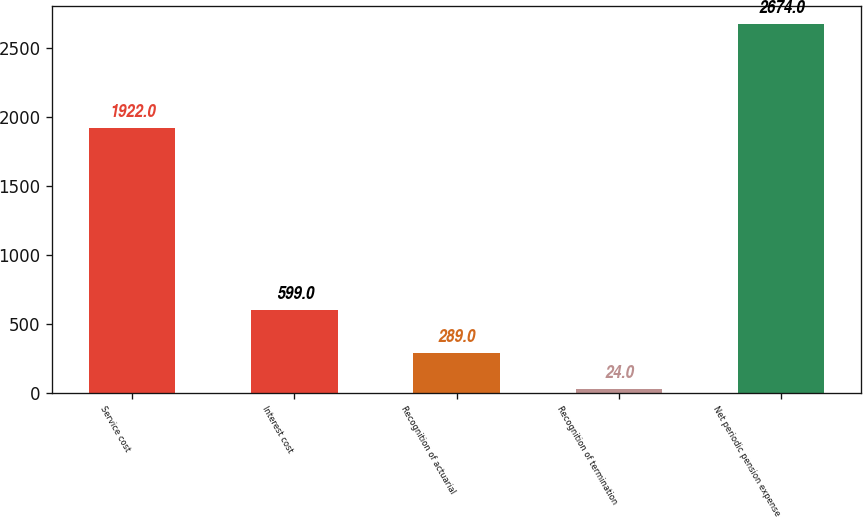<chart> <loc_0><loc_0><loc_500><loc_500><bar_chart><fcel>Service cost<fcel>Interest cost<fcel>Recognition of actuarial<fcel>Recognition of termination<fcel>Net periodic pension expense<nl><fcel>1922<fcel>599<fcel>289<fcel>24<fcel>2674<nl></chart> 